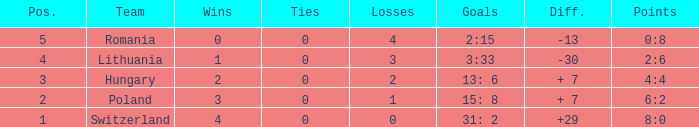Which team had fewer than 2 losses and a position number more than 1? Poland. 